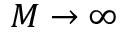Convert formula to latex. <formula><loc_0><loc_0><loc_500><loc_500>M \to \infty</formula> 